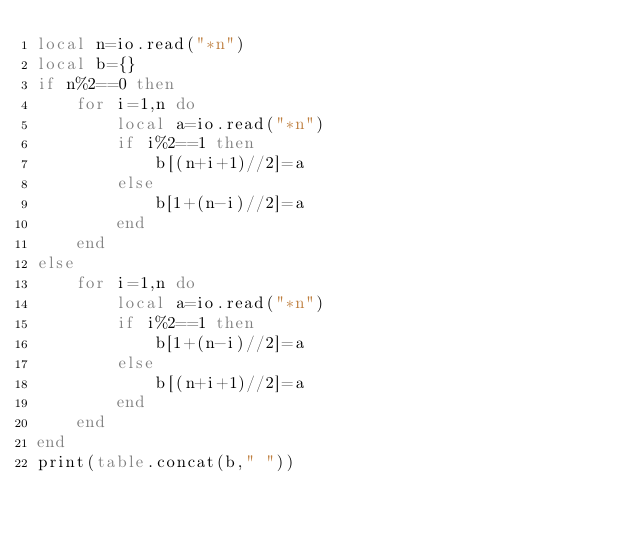<code> <loc_0><loc_0><loc_500><loc_500><_Lua_>local n=io.read("*n")
local b={}
if n%2==0 then
    for i=1,n do
        local a=io.read("*n")
        if i%2==1 then
            b[(n+i+1)//2]=a
        else
            b[1+(n-i)//2]=a
        end
    end
else
    for i=1,n do
        local a=io.read("*n")
        if i%2==1 then
            b[1+(n-i)//2]=a
        else
            b[(n+i+1)//2]=a
        end
    end
end
print(table.concat(b," "))</code> 